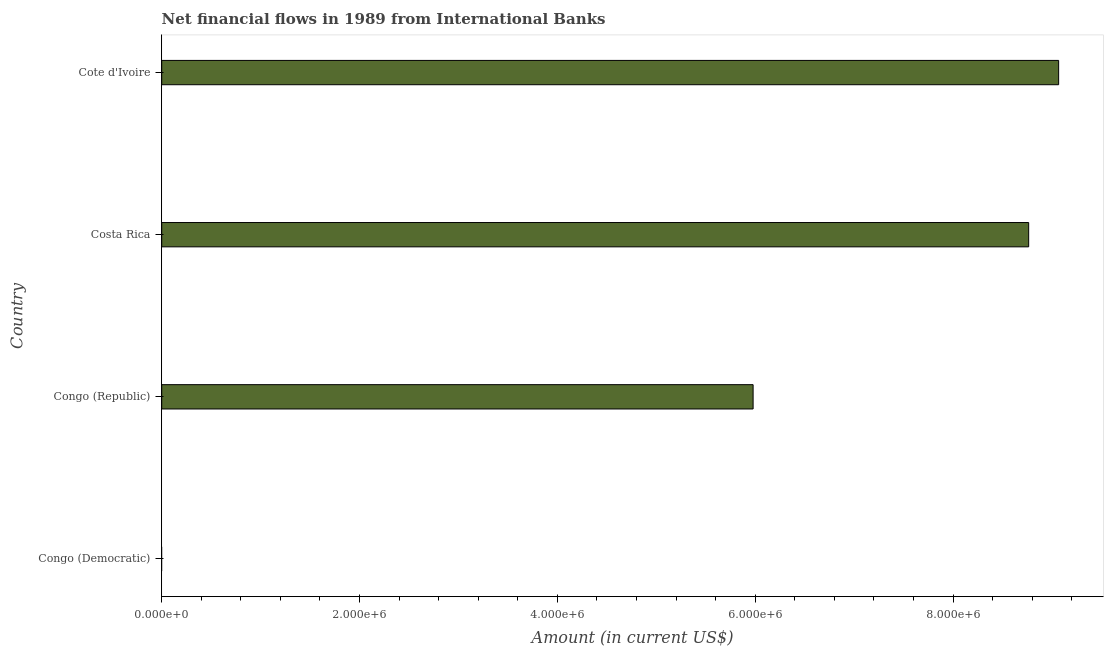Does the graph contain any zero values?
Keep it short and to the point. Yes. Does the graph contain grids?
Your answer should be very brief. No. What is the title of the graph?
Make the answer very short. Net financial flows in 1989 from International Banks. What is the label or title of the X-axis?
Provide a short and direct response. Amount (in current US$). What is the label or title of the Y-axis?
Your answer should be very brief. Country. What is the net financial flows from ibrd in Congo (Democratic)?
Give a very brief answer. 0. Across all countries, what is the maximum net financial flows from ibrd?
Your answer should be compact. 9.07e+06. In which country was the net financial flows from ibrd maximum?
Provide a short and direct response. Cote d'Ivoire. What is the sum of the net financial flows from ibrd?
Offer a terse response. 2.38e+07. What is the difference between the net financial flows from ibrd in Congo (Republic) and Cote d'Ivoire?
Keep it short and to the point. -3.09e+06. What is the average net financial flows from ibrd per country?
Your response must be concise. 5.95e+06. What is the median net financial flows from ibrd?
Offer a terse response. 7.37e+06. What is the ratio of the net financial flows from ibrd in Congo (Republic) to that in Cote d'Ivoire?
Keep it short and to the point. 0.66. Is the difference between the net financial flows from ibrd in Costa Rica and Cote d'Ivoire greater than the difference between any two countries?
Offer a very short reply. No. What is the difference between the highest and the second highest net financial flows from ibrd?
Keep it short and to the point. 3.03e+05. What is the difference between the highest and the lowest net financial flows from ibrd?
Ensure brevity in your answer.  9.07e+06. In how many countries, is the net financial flows from ibrd greater than the average net financial flows from ibrd taken over all countries?
Keep it short and to the point. 3. How many bars are there?
Your response must be concise. 3. Are all the bars in the graph horizontal?
Keep it short and to the point. Yes. What is the Amount (in current US$) in Congo (Democratic)?
Give a very brief answer. 0. What is the Amount (in current US$) in Congo (Republic)?
Your answer should be very brief. 5.98e+06. What is the Amount (in current US$) of Costa Rica?
Your answer should be very brief. 8.76e+06. What is the Amount (in current US$) in Cote d'Ivoire?
Keep it short and to the point. 9.07e+06. What is the difference between the Amount (in current US$) in Congo (Republic) and Costa Rica?
Offer a very short reply. -2.79e+06. What is the difference between the Amount (in current US$) in Congo (Republic) and Cote d'Ivoire?
Provide a succinct answer. -3.09e+06. What is the difference between the Amount (in current US$) in Costa Rica and Cote d'Ivoire?
Offer a very short reply. -3.03e+05. What is the ratio of the Amount (in current US$) in Congo (Republic) to that in Costa Rica?
Offer a terse response. 0.68. What is the ratio of the Amount (in current US$) in Congo (Republic) to that in Cote d'Ivoire?
Keep it short and to the point. 0.66. 